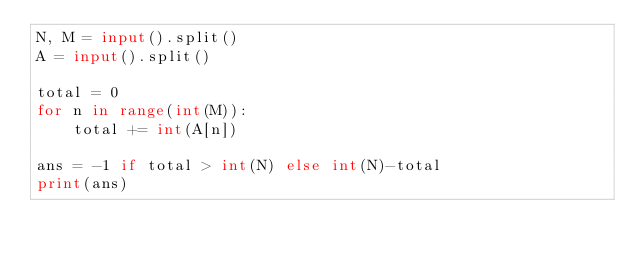<code> <loc_0><loc_0><loc_500><loc_500><_Python_>N, M = input().split()
A = input().split()

total = 0
for n in range(int(M)):
    total += int(A[n])

ans = -1 if total > int(N) else int(N)-total
print(ans)</code> 